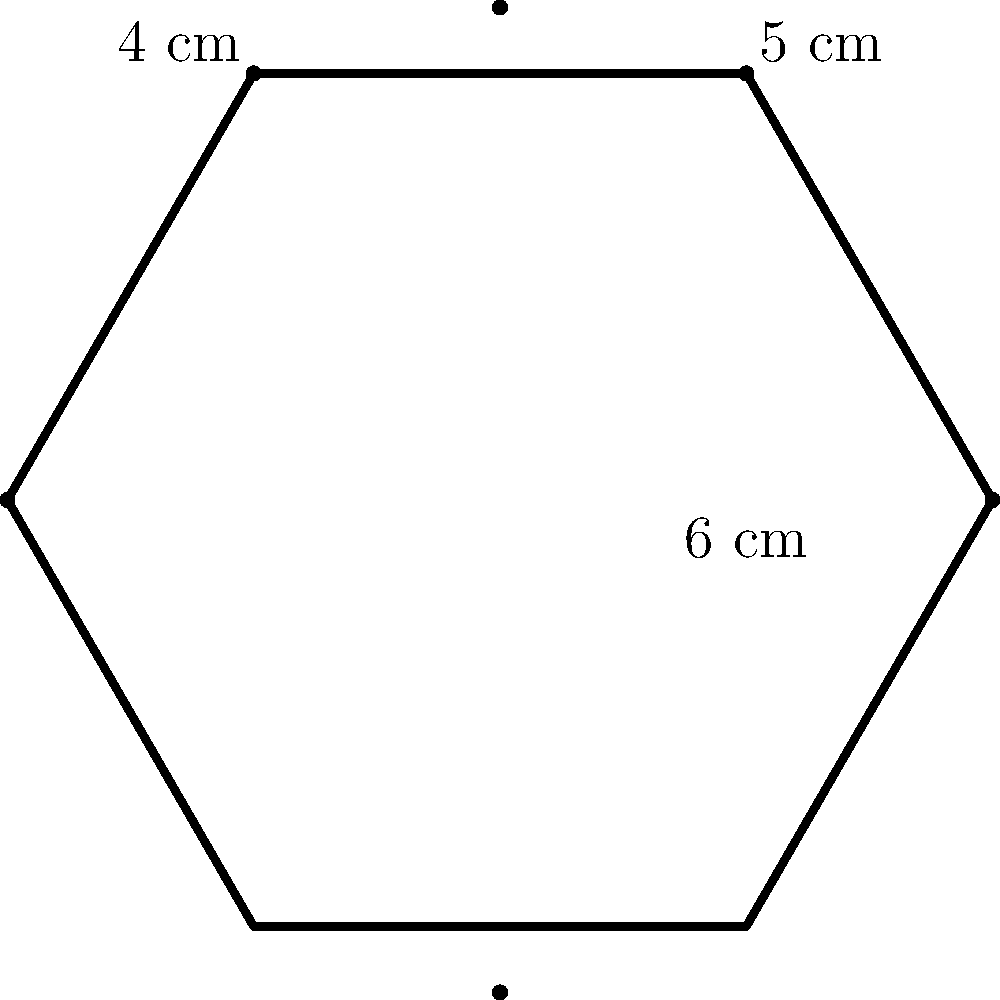Krzysztof Gonciarz received a custom YouTube play button in the shape of an irregular hexagon. The lengths of three consecutive sides are 6 cm, 4 cm, and 5 cm, as shown in the diagram. If the perimeter of the play button is 30 cm, what is the sum of the lengths of the other three sides? Let's approach this step-by-step:

1) First, we need to identify what we know:
   - The play button is an irregular hexagon
   - Three consecutive sides measure 6 cm, 4 cm, and 5 cm
   - The total perimeter is 30 cm

2) Let's define variables for the unknown sides:
   Let $a$, $b$, and $c$ be the lengths of the other three sides.

3) We can set up an equation based on the perimeter:
   $6 + 4 + 5 + a + b + c = 30$

4) Simplify the known parts:
   $15 + a + b + c = 30$

5) Subtract 15 from both sides:
   $a + b + c = 30 - 15 = 15$

Therefore, the sum of the lengths of the other three sides is 15 cm.
Answer: 15 cm 